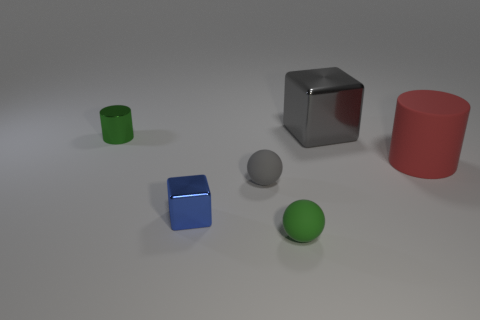Is there a small gray thing that has the same shape as the tiny green metal thing?
Give a very brief answer. No. How many things are either green rubber balls or small rubber spheres?
Provide a succinct answer. 2. What number of green metal things are in front of the green object behind the object on the right side of the large shiny block?
Offer a very short reply. 0. What material is the other thing that is the same shape as the large shiny object?
Offer a terse response. Metal. There is a object that is in front of the large metallic cube and to the right of the green ball; what is it made of?
Your answer should be compact. Rubber. Are there fewer matte balls that are on the right side of the gray matte object than green metallic cylinders in front of the tiny blue metallic thing?
Your answer should be very brief. No. How many other things are there of the same size as the gray ball?
Make the answer very short. 3. There is a object that is behind the small object that is behind the cylinder to the right of the tiny green ball; what shape is it?
Ensure brevity in your answer.  Cube. What number of gray objects are large blocks or matte things?
Provide a short and direct response. 2. How many cylinders are behind the tiny metallic thing that is behind the red cylinder?
Ensure brevity in your answer.  0. 